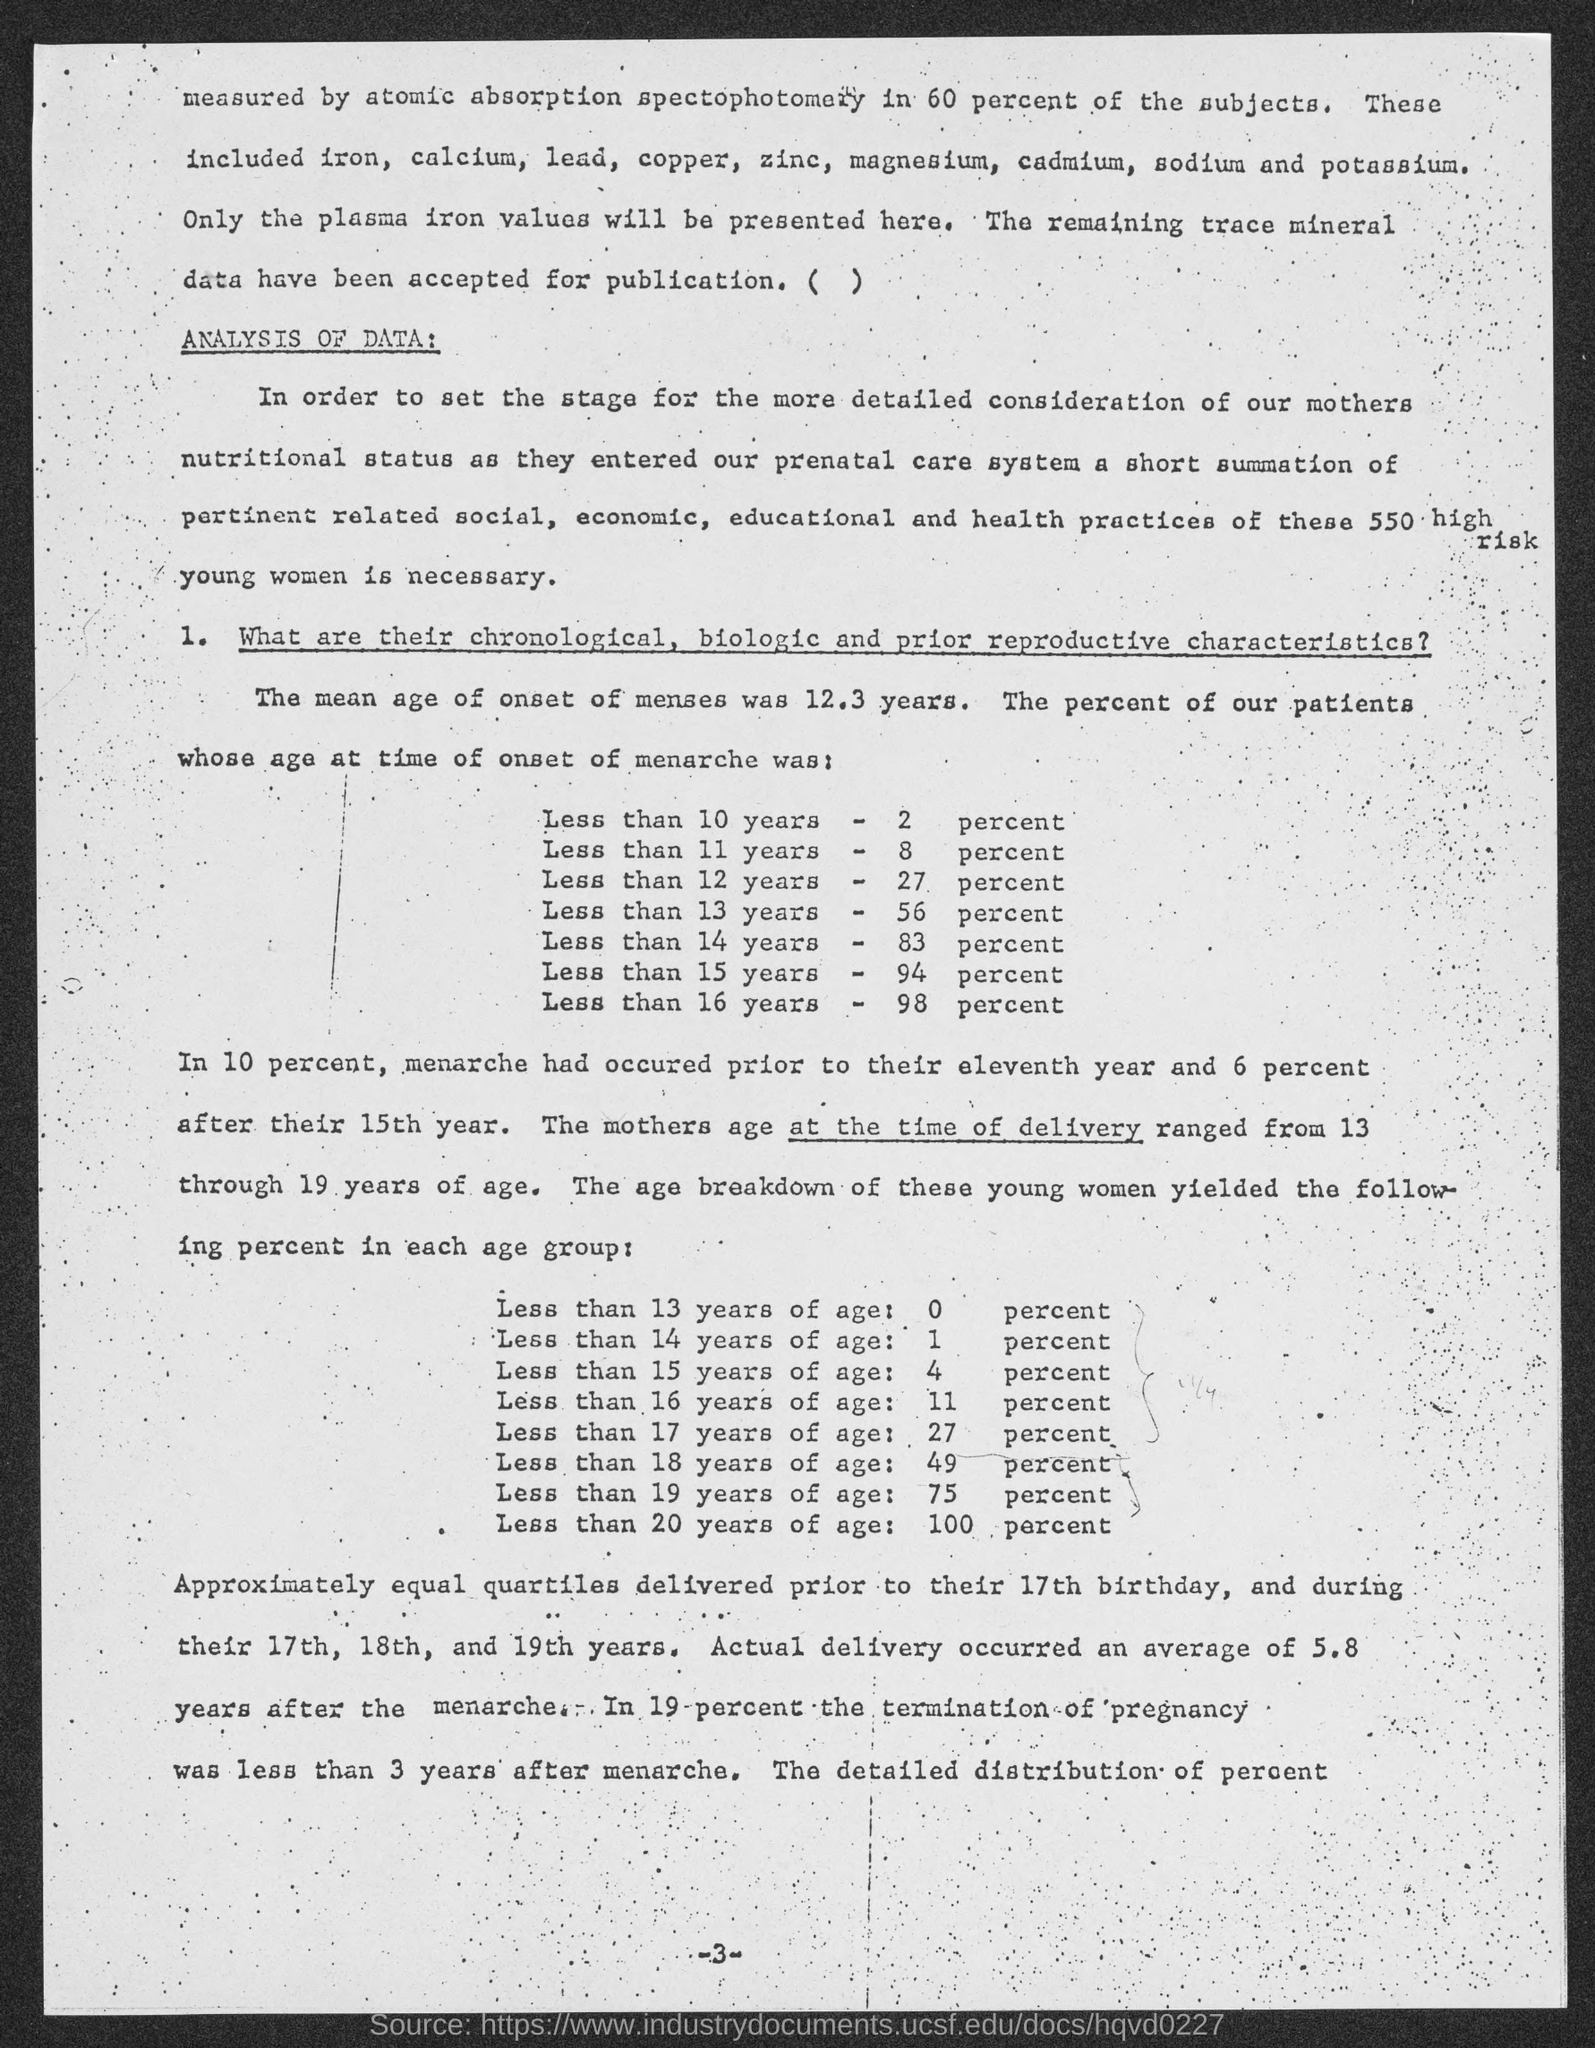Specify some key components in this picture. The study found that 94% of the patients whose age at the time of onset of menses was less than 15 years had a specific condition. Out of all patients who had their menstrual onset before the age of 14, 83% of them experienced their menstrual onset before the age of 14. The mean age of onset of menarche, or the first menstrual period, is 12.3 years. In this data, 27% of patients had an age at the onset of menses of less than 12 years. The study found that 8% of patients whose age at the time of onset of menses was less than 11 years had the condition under investigation. 